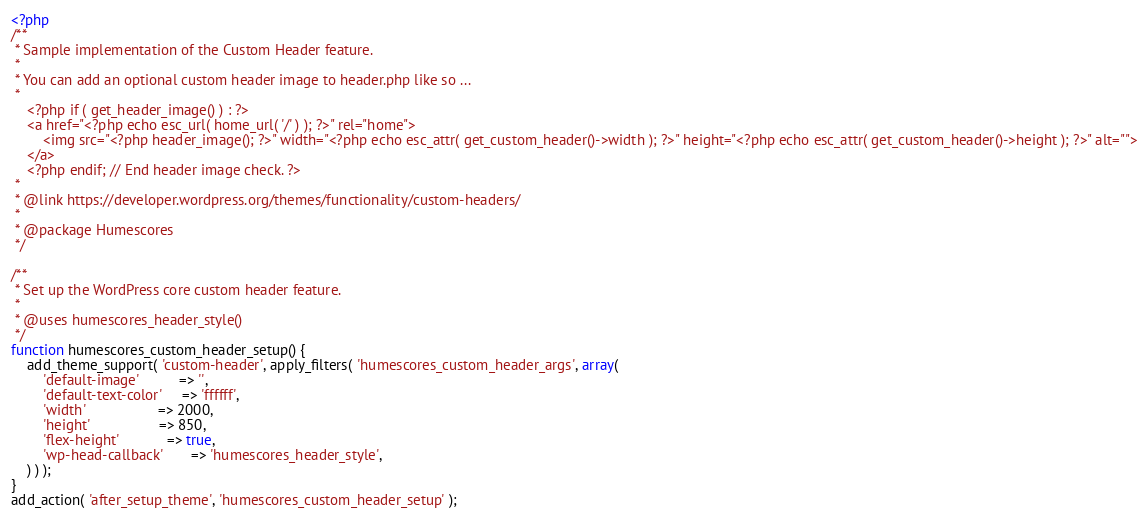<code> <loc_0><loc_0><loc_500><loc_500><_PHP_><?php
/**
 * Sample implementation of the Custom Header feature.
 *
 * You can add an optional custom header image to header.php like so ...
 *
	<?php if ( get_header_image() ) : ?>
	<a href="<?php echo esc_url( home_url( '/' ) ); ?>" rel="home">
		<img src="<?php header_image(); ?>" width="<?php echo esc_attr( get_custom_header()->width ); ?>" height="<?php echo esc_attr( get_custom_header()->height ); ?>" alt="">
	</a>
	<?php endif; // End header image check. ?>
 *
 * @link https://developer.wordpress.org/themes/functionality/custom-headers/
 *
 * @package Humescores
 */

/**
 * Set up the WordPress core custom header feature.
 *
 * @uses humescores_header_style()
 */
function humescores_custom_header_setup() {
	add_theme_support( 'custom-header', apply_filters( 'humescores_custom_header_args', array(
		'default-image'          => '',
		'default-text-color'     => 'ffffff',
		'width'                  => 2000,
		'height'                 => 850,
		'flex-height'            => true,
		'wp-head-callback'       => 'humescores_header_style',
	) ) );
}
add_action( 'after_setup_theme', 'humescores_custom_header_setup' );
</code> 